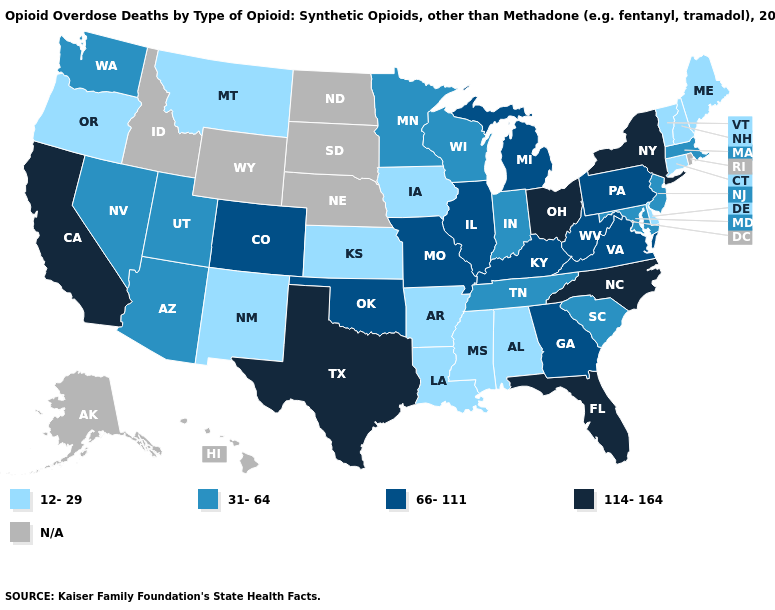Which states have the lowest value in the USA?
Concise answer only. Alabama, Arkansas, Connecticut, Delaware, Iowa, Kansas, Louisiana, Maine, Mississippi, Montana, New Hampshire, New Mexico, Oregon, Vermont. Does New Jersey have the lowest value in the Northeast?
Write a very short answer. No. Among the states that border Nebraska , which have the highest value?
Quick response, please. Colorado, Missouri. Name the states that have a value in the range 66-111?
Answer briefly. Colorado, Georgia, Illinois, Kentucky, Michigan, Missouri, Oklahoma, Pennsylvania, Virginia, West Virginia. Among the states that border Illinois , which have the highest value?
Short answer required. Kentucky, Missouri. Which states have the highest value in the USA?
Be succinct. California, Florida, New York, North Carolina, Ohio, Texas. What is the lowest value in states that border Kentucky?
Keep it brief. 31-64. Which states have the highest value in the USA?
Keep it brief. California, Florida, New York, North Carolina, Ohio, Texas. What is the value of Missouri?
Short answer required. 66-111. Name the states that have a value in the range 31-64?
Answer briefly. Arizona, Indiana, Maryland, Massachusetts, Minnesota, Nevada, New Jersey, South Carolina, Tennessee, Utah, Washington, Wisconsin. What is the value of New Jersey?
Keep it brief. 31-64. Name the states that have a value in the range 114-164?
Give a very brief answer. California, Florida, New York, North Carolina, Ohio, Texas. Which states have the lowest value in the West?
Short answer required. Montana, New Mexico, Oregon. 